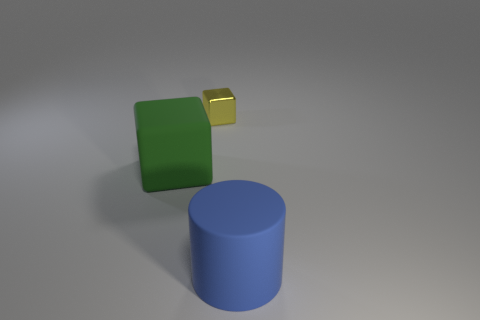Add 3 big green rubber objects. How many objects exist? 6 Subtract all cylinders. How many objects are left? 2 Subtract all metallic cubes. Subtract all big rubber blocks. How many objects are left? 1 Add 2 cubes. How many cubes are left? 4 Add 2 yellow shiny blocks. How many yellow shiny blocks exist? 3 Subtract 0 blue cubes. How many objects are left? 3 